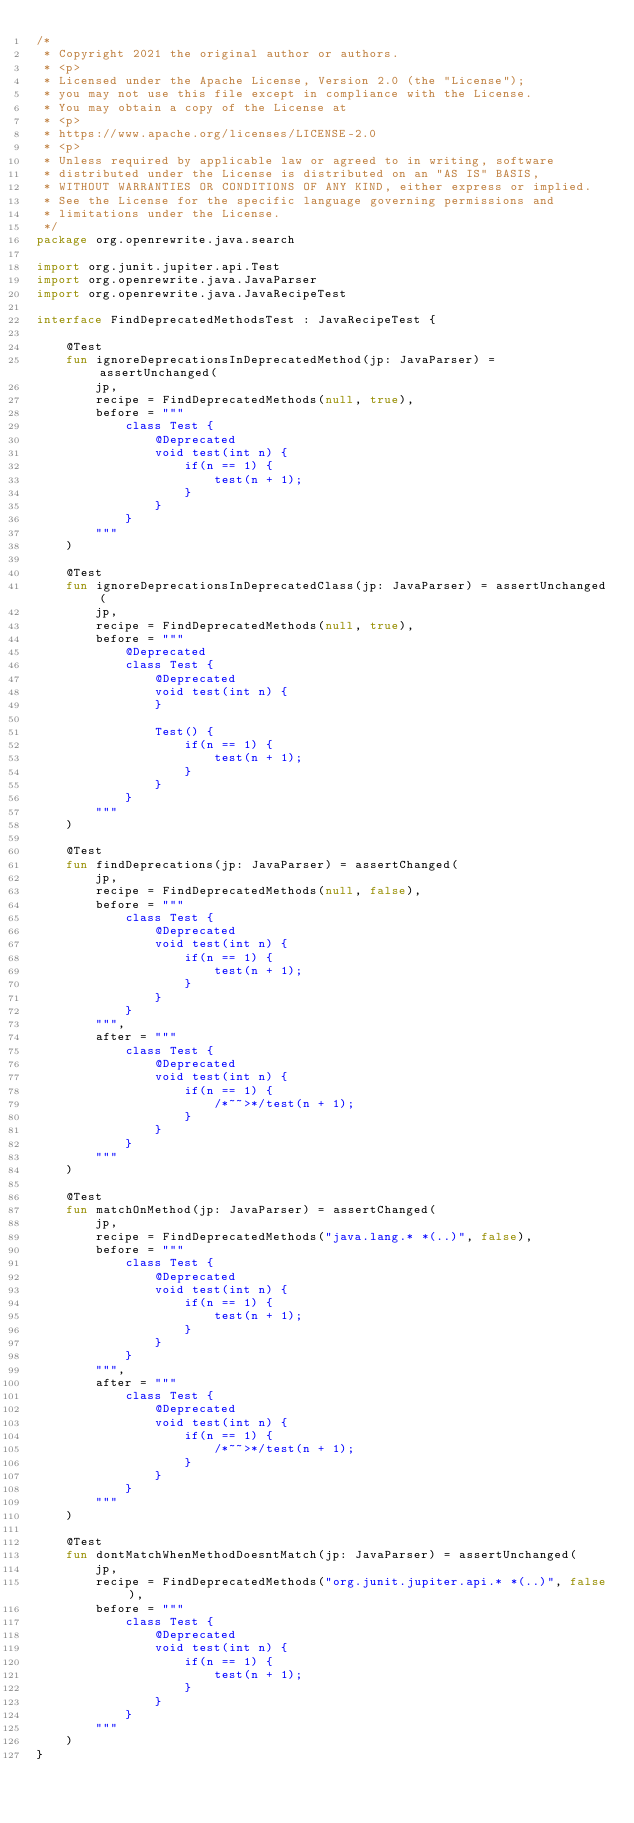<code> <loc_0><loc_0><loc_500><loc_500><_Kotlin_>/*
 * Copyright 2021 the original author or authors.
 * <p>
 * Licensed under the Apache License, Version 2.0 (the "License");
 * you may not use this file except in compliance with the License.
 * You may obtain a copy of the License at
 * <p>
 * https://www.apache.org/licenses/LICENSE-2.0
 * <p>
 * Unless required by applicable law or agreed to in writing, software
 * distributed under the License is distributed on an "AS IS" BASIS,
 * WITHOUT WARRANTIES OR CONDITIONS OF ANY KIND, either express or implied.
 * See the License for the specific language governing permissions and
 * limitations under the License.
 */
package org.openrewrite.java.search

import org.junit.jupiter.api.Test
import org.openrewrite.java.JavaParser
import org.openrewrite.java.JavaRecipeTest

interface FindDeprecatedMethodsTest : JavaRecipeTest {

    @Test
    fun ignoreDeprecationsInDeprecatedMethod(jp: JavaParser) = assertUnchanged(
        jp,
        recipe = FindDeprecatedMethods(null, true),
        before = """
            class Test {
                @Deprecated
                void test(int n) {
                    if(n == 1) {
                        test(n + 1);
                    }
                }
            }
        """
    )

    @Test
    fun ignoreDeprecationsInDeprecatedClass(jp: JavaParser) = assertUnchanged(
        jp,
        recipe = FindDeprecatedMethods(null, true),
        before = """
            @Deprecated
            class Test {
                @Deprecated
                void test(int n) {
                }
                
                Test() {
                    if(n == 1) {
                        test(n + 1);
                    }
                }
            }
        """
    )

    @Test
    fun findDeprecations(jp: JavaParser) = assertChanged(
        jp,
        recipe = FindDeprecatedMethods(null, false),
        before = """
            class Test {
                @Deprecated
                void test(int n) {
                    if(n == 1) {
                        test(n + 1);
                    }
                }
            }
        """,
        after = """
            class Test {
                @Deprecated
                void test(int n) {
                    if(n == 1) {
                        /*~~>*/test(n + 1);
                    }
                }
            }
        """
    )

    @Test
    fun matchOnMethod(jp: JavaParser) = assertChanged(
        jp,
        recipe = FindDeprecatedMethods("java.lang.* *(..)", false),
        before = """
            class Test {
                @Deprecated
                void test(int n) {
                    if(n == 1) {
                        test(n + 1);
                    }
                }
            }
        """,
        after = """
            class Test {
                @Deprecated
                void test(int n) {
                    if(n == 1) {
                        /*~~>*/test(n + 1);
                    }
                }
            }
        """
    )

    @Test
    fun dontMatchWhenMethodDoesntMatch(jp: JavaParser) = assertUnchanged(
        jp,
        recipe = FindDeprecatedMethods("org.junit.jupiter.api.* *(..)", false),
        before = """
            class Test {
                @Deprecated
                void test(int n) {
                    if(n == 1) {
                        test(n + 1);
                    }
                }
            }
        """
    )
}
</code> 